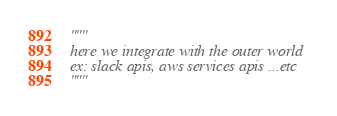Convert code to text. <code><loc_0><loc_0><loc_500><loc_500><_Python_>"""
here we integrate with the outer world
ex: slack apis, aws services apis ...etc
"""
</code> 